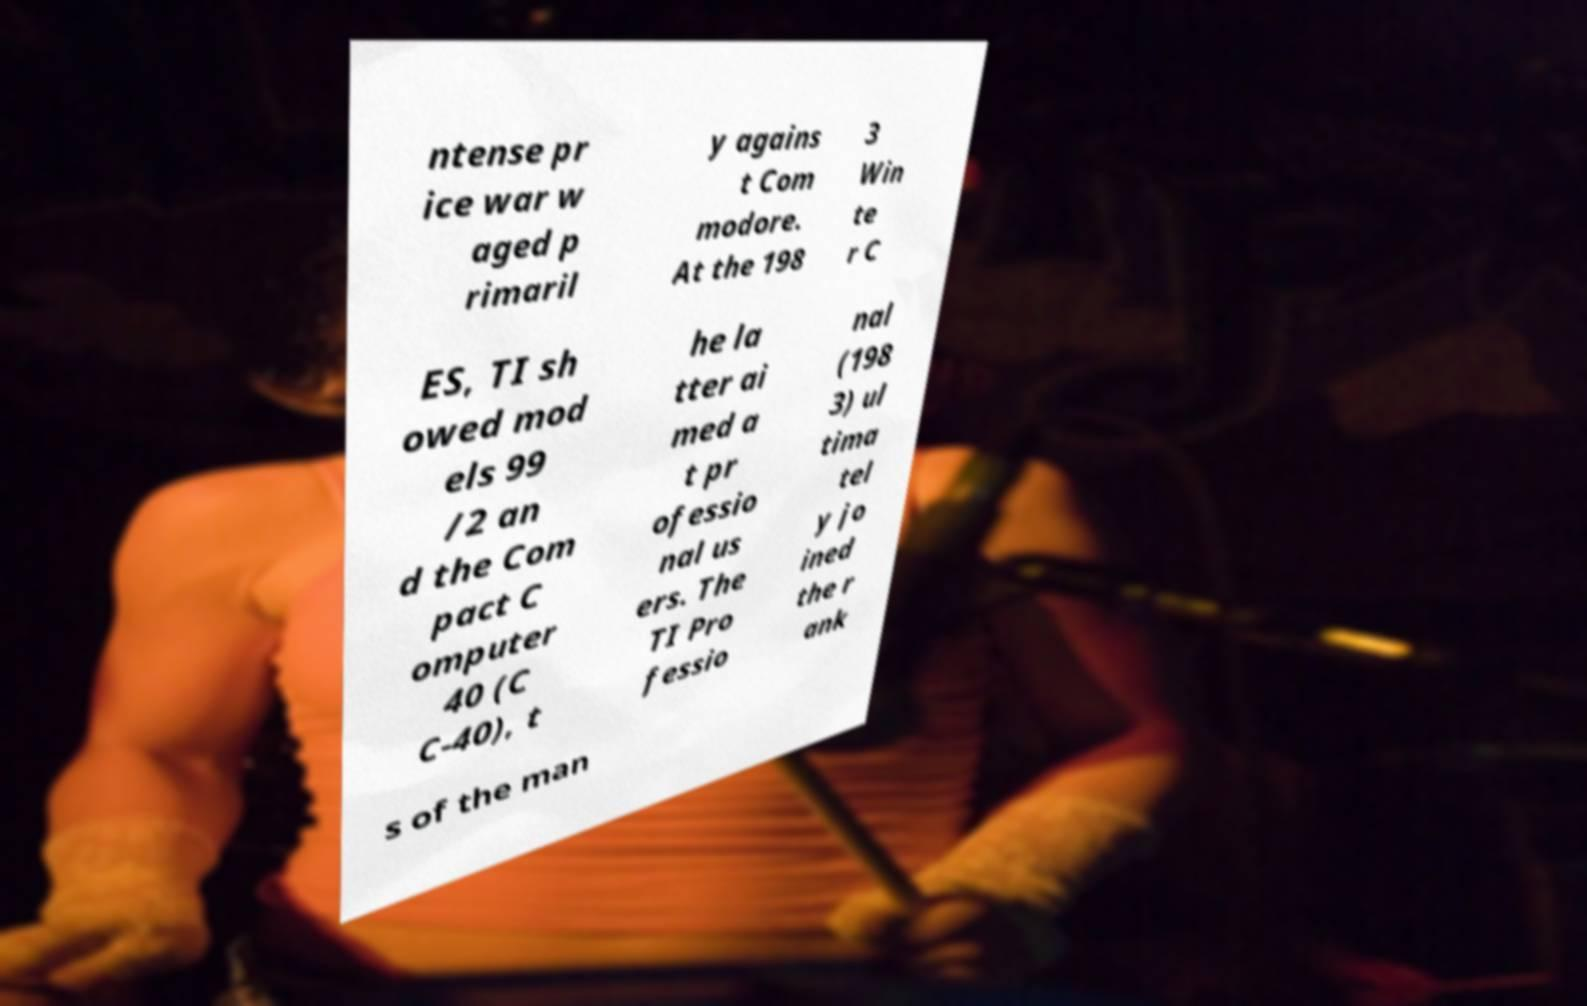Please read and relay the text visible in this image. What does it say? ntense pr ice war w aged p rimaril y agains t Com modore. At the 198 3 Win te r C ES, TI sh owed mod els 99 /2 an d the Com pact C omputer 40 (C C-40), t he la tter ai med a t pr ofessio nal us ers. The TI Pro fessio nal (198 3) ul tima tel y jo ined the r ank s of the man 